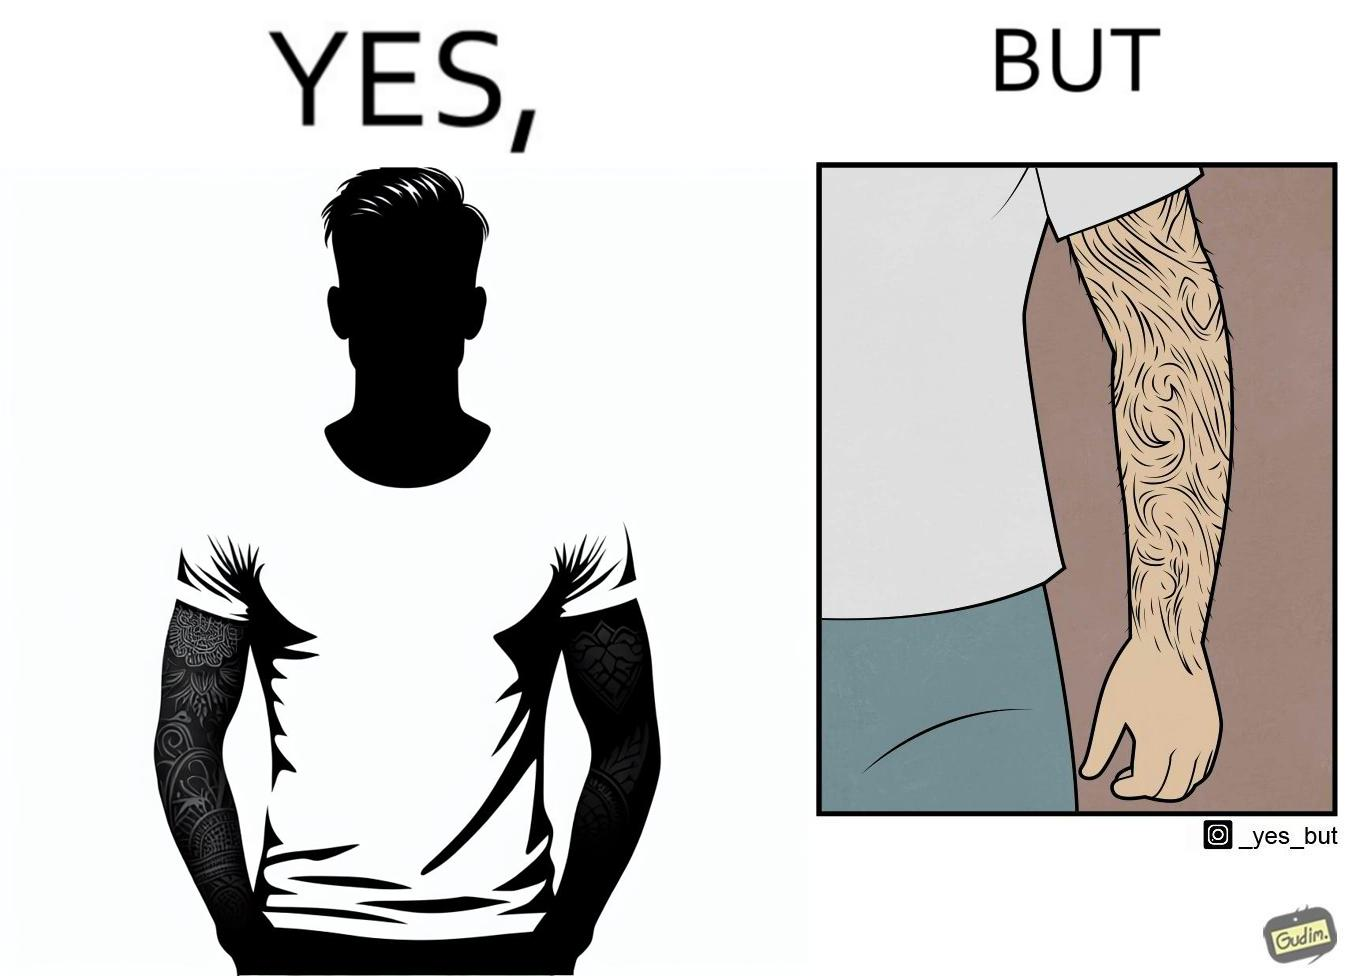Is this a satirical image? Yes, this image is satirical. 